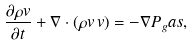Convert formula to latex. <formula><loc_0><loc_0><loc_500><loc_500>\frac { \partial \rho v } { \partial t } + \nabla \cdot ( \rho v \, v ) = - \nabla P _ { g } a s ,</formula> 